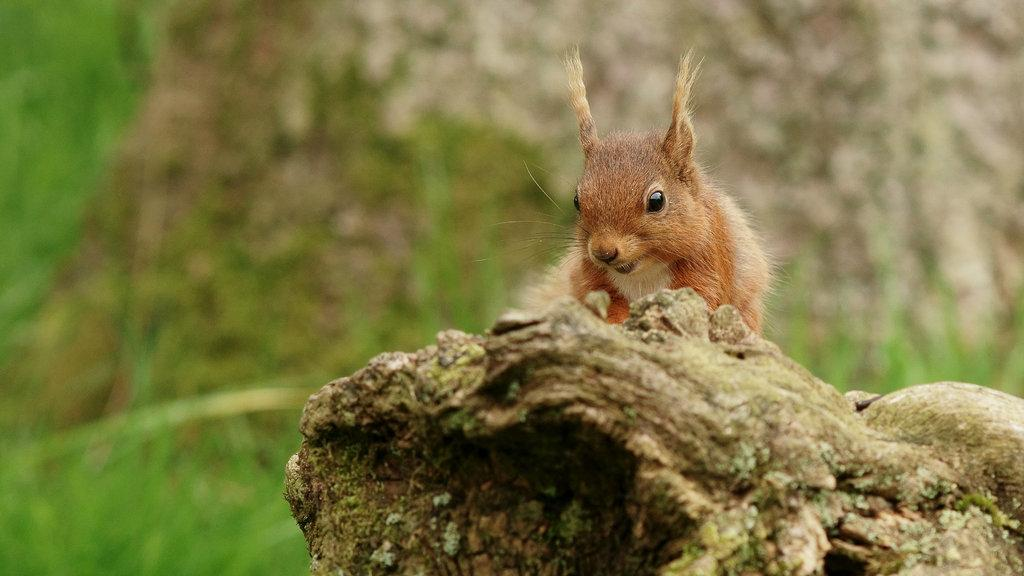What type of animal is in the picture? There is a fox squirrel in the picture. What type of vegetation is at the bottom of the image? There is grass at the bottom of the image. Can you describe the background of the image? The background of the image is blurry. What type of cable can be seen in the image? There is no cable present in the image. What type of plantation is visible in the background of the image? There is no plantation visible in the image; the background is blurry. 